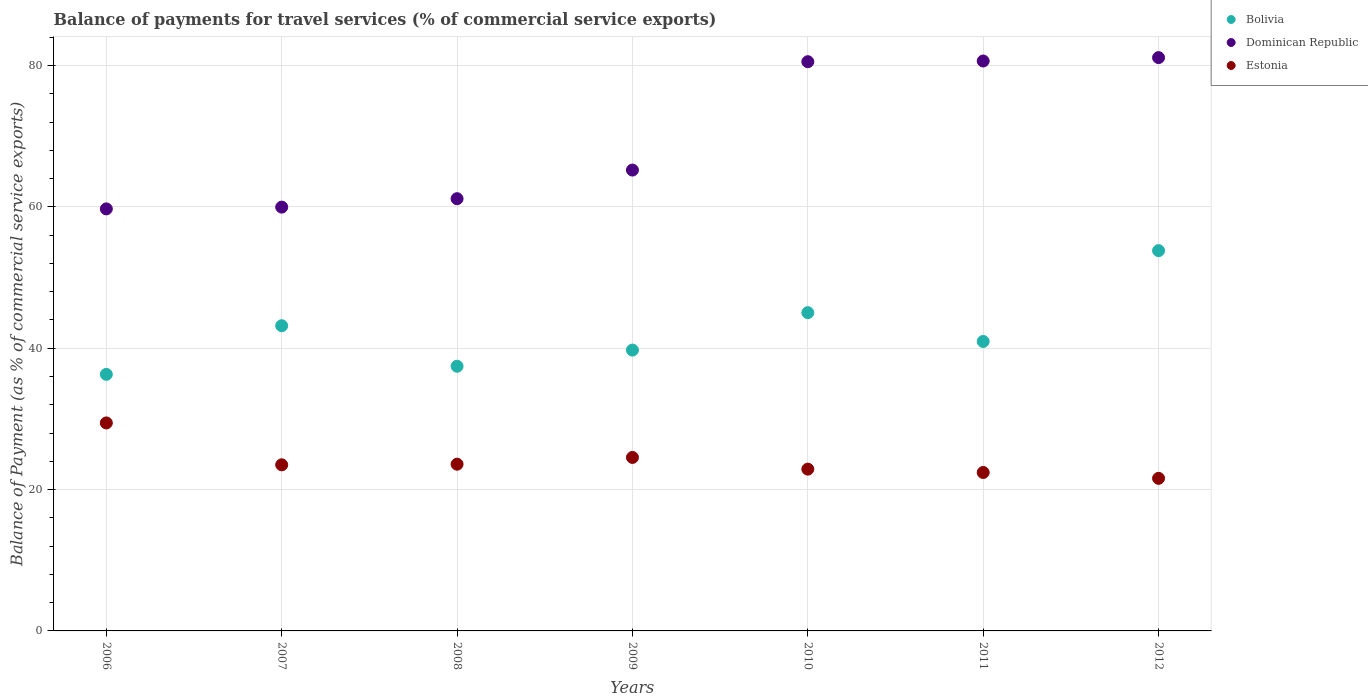How many different coloured dotlines are there?
Make the answer very short. 3. What is the balance of payments for travel services in Dominican Republic in 2009?
Offer a terse response. 65.2. Across all years, what is the maximum balance of payments for travel services in Bolivia?
Offer a very short reply. 53.8. Across all years, what is the minimum balance of payments for travel services in Dominican Republic?
Provide a short and direct response. 59.71. In which year was the balance of payments for travel services in Bolivia maximum?
Provide a short and direct response. 2012. In which year was the balance of payments for travel services in Bolivia minimum?
Give a very brief answer. 2006. What is the total balance of payments for travel services in Estonia in the graph?
Keep it short and to the point. 167.94. What is the difference between the balance of payments for travel services in Dominican Republic in 2007 and that in 2011?
Make the answer very short. -20.67. What is the difference between the balance of payments for travel services in Dominican Republic in 2006 and the balance of payments for travel services in Estonia in 2012?
Your answer should be compact. 38.12. What is the average balance of payments for travel services in Dominican Republic per year?
Your answer should be compact. 69.75. In the year 2007, what is the difference between the balance of payments for travel services in Dominican Republic and balance of payments for travel services in Estonia?
Provide a succinct answer. 36.46. What is the ratio of the balance of payments for travel services in Estonia in 2007 to that in 2009?
Provide a succinct answer. 0.96. Is the balance of payments for travel services in Dominican Republic in 2009 less than that in 2012?
Provide a short and direct response. Yes. Is the difference between the balance of payments for travel services in Dominican Republic in 2007 and 2011 greater than the difference between the balance of payments for travel services in Estonia in 2007 and 2011?
Provide a succinct answer. No. What is the difference between the highest and the second highest balance of payments for travel services in Estonia?
Your answer should be very brief. 4.88. What is the difference between the highest and the lowest balance of payments for travel services in Dominican Republic?
Make the answer very short. 21.4. Is it the case that in every year, the sum of the balance of payments for travel services in Bolivia and balance of payments for travel services in Estonia  is greater than the balance of payments for travel services in Dominican Republic?
Provide a succinct answer. No. Is the balance of payments for travel services in Bolivia strictly greater than the balance of payments for travel services in Dominican Republic over the years?
Your answer should be compact. No. Is the balance of payments for travel services in Estonia strictly less than the balance of payments for travel services in Dominican Republic over the years?
Keep it short and to the point. Yes. How many years are there in the graph?
Ensure brevity in your answer.  7. Does the graph contain grids?
Your response must be concise. Yes. Where does the legend appear in the graph?
Your response must be concise. Top right. What is the title of the graph?
Provide a succinct answer. Balance of payments for travel services (% of commercial service exports). What is the label or title of the Y-axis?
Provide a short and direct response. Balance of Payment (as % of commercial service exports). What is the Balance of Payment (as % of commercial service exports) in Bolivia in 2006?
Provide a short and direct response. 36.3. What is the Balance of Payment (as % of commercial service exports) in Dominican Republic in 2006?
Offer a terse response. 59.71. What is the Balance of Payment (as % of commercial service exports) in Estonia in 2006?
Your answer should be very brief. 29.43. What is the Balance of Payment (as % of commercial service exports) of Bolivia in 2007?
Provide a succinct answer. 43.18. What is the Balance of Payment (as % of commercial service exports) of Dominican Republic in 2007?
Ensure brevity in your answer.  59.96. What is the Balance of Payment (as % of commercial service exports) in Estonia in 2007?
Your response must be concise. 23.5. What is the Balance of Payment (as % of commercial service exports) of Bolivia in 2008?
Keep it short and to the point. 37.45. What is the Balance of Payment (as % of commercial service exports) in Dominican Republic in 2008?
Offer a very short reply. 61.15. What is the Balance of Payment (as % of commercial service exports) of Estonia in 2008?
Provide a succinct answer. 23.59. What is the Balance of Payment (as % of commercial service exports) of Bolivia in 2009?
Provide a short and direct response. 39.73. What is the Balance of Payment (as % of commercial service exports) of Dominican Republic in 2009?
Give a very brief answer. 65.2. What is the Balance of Payment (as % of commercial service exports) in Estonia in 2009?
Make the answer very short. 24.54. What is the Balance of Payment (as % of commercial service exports) of Bolivia in 2010?
Ensure brevity in your answer.  45.03. What is the Balance of Payment (as % of commercial service exports) of Dominican Republic in 2010?
Give a very brief answer. 80.53. What is the Balance of Payment (as % of commercial service exports) in Estonia in 2010?
Ensure brevity in your answer.  22.89. What is the Balance of Payment (as % of commercial service exports) of Bolivia in 2011?
Your answer should be compact. 40.95. What is the Balance of Payment (as % of commercial service exports) in Dominican Republic in 2011?
Ensure brevity in your answer.  80.63. What is the Balance of Payment (as % of commercial service exports) in Estonia in 2011?
Your answer should be compact. 22.41. What is the Balance of Payment (as % of commercial service exports) in Bolivia in 2012?
Your answer should be very brief. 53.8. What is the Balance of Payment (as % of commercial service exports) in Dominican Republic in 2012?
Your answer should be very brief. 81.11. What is the Balance of Payment (as % of commercial service exports) in Estonia in 2012?
Offer a very short reply. 21.59. Across all years, what is the maximum Balance of Payment (as % of commercial service exports) in Bolivia?
Your answer should be compact. 53.8. Across all years, what is the maximum Balance of Payment (as % of commercial service exports) in Dominican Republic?
Offer a terse response. 81.11. Across all years, what is the maximum Balance of Payment (as % of commercial service exports) of Estonia?
Your response must be concise. 29.43. Across all years, what is the minimum Balance of Payment (as % of commercial service exports) in Bolivia?
Your answer should be very brief. 36.3. Across all years, what is the minimum Balance of Payment (as % of commercial service exports) in Dominican Republic?
Give a very brief answer. 59.71. Across all years, what is the minimum Balance of Payment (as % of commercial service exports) in Estonia?
Your answer should be very brief. 21.59. What is the total Balance of Payment (as % of commercial service exports) in Bolivia in the graph?
Make the answer very short. 296.43. What is the total Balance of Payment (as % of commercial service exports) in Dominican Republic in the graph?
Your response must be concise. 488.28. What is the total Balance of Payment (as % of commercial service exports) in Estonia in the graph?
Your answer should be compact. 167.94. What is the difference between the Balance of Payment (as % of commercial service exports) in Bolivia in 2006 and that in 2007?
Give a very brief answer. -6.88. What is the difference between the Balance of Payment (as % of commercial service exports) of Dominican Republic in 2006 and that in 2007?
Offer a terse response. -0.25. What is the difference between the Balance of Payment (as % of commercial service exports) of Estonia in 2006 and that in 2007?
Make the answer very short. 5.93. What is the difference between the Balance of Payment (as % of commercial service exports) of Bolivia in 2006 and that in 2008?
Keep it short and to the point. -1.15. What is the difference between the Balance of Payment (as % of commercial service exports) in Dominican Republic in 2006 and that in 2008?
Offer a very short reply. -1.44. What is the difference between the Balance of Payment (as % of commercial service exports) in Estonia in 2006 and that in 2008?
Your answer should be compact. 5.84. What is the difference between the Balance of Payment (as % of commercial service exports) in Bolivia in 2006 and that in 2009?
Offer a very short reply. -3.43. What is the difference between the Balance of Payment (as % of commercial service exports) in Dominican Republic in 2006 and that in 2009?
Keep it short and to the point. -5.49. What is the difference between the Balance of Payment (as % of commercial service exports) in Estonia in 2006 and that in 2009?
Make the answer very short. 4.88. What is the difference between the Balance of Payment (as % of commercial service exports) of Bolivia in 2006 and that in 2010?
Offer a terse response. -8.73. What is the difference between the Balance of Payment (as % of commercial service exports) of Dominican Republic in 2006 and that in 2010?
Make the answer very short. -20.82. What is the difference between the Balance of Payment (as % of commercial service exports) in Estonia in 2006 and that in 2010?
Provide a short and direct response. 6.54. What is the difference between the Balance of Payment (as % of commercial service exports) of Bolivia in 2006 and that in 2011?
Offer a terse response. -4.65. What is the difference between the Balance of Payment (as % of commercial service exports) of Dominican Republic in 2006 and that in 2011?
Your answer should be compact. -20.92. What is the difference between the Balance of Payment (as % of commercial service exports) of Estonia in 2006 and that in 2011?
Your response must be concise. 7.01. What is the difference between the Balance of Payment (as % of commercial service exports) in Bolivia in 2006 and that in 2012?
Your answer should be compact. -17.5. What is the difference between the Balance of Payment (as % of commercial service exports) in Dominican Republic in 2006 and that in 2012?
Your response must be concise. -21.4. What is the difference between the Balance of Payment (as % of commercial service exports) in Estonia in 2006 and that in 2012?
Ensure brevity in your answer.  7.84. What is the difference between the Balance of Payment (as % of commercial service exports) in Bolivia in 2007 and that in 2008?
Your answer should be compact. 5.73. What is the difference between the Balance of Payment (as % of commercial service exports) in Dominican Republic in 2007 and that in 2008?
Make the answer very short. -1.19. What is the difference between the Balance of Payment (as % of commercial service exports) of Estonia in 2007 and that in 2008?
Offer a terse response. -0.09. What is the difference between the Balance of Payment (as % of commercial service exports) of Bolivia in 2007 and that in 2009?
Offer a very short reply. 3.45. What is the difference between the Balance of Payment (as % of commercial service exports) of Dominican Republic in 2007 and that in 2009?
Ensure brevity in your answer.  -5.24. What is the difference between the Balance of Payment (as % of commercial service exports) in Estonia in 2007 and that in 2009?
Your answer should be very brief. -1.04. What is the difference between the Balance of Payment (as % of commercial service exports) in Bolivia in 2007 and that in 2010?
Your answer should be compact. -1.85. What is the difference between the Balance of Payment (as % of commercial service exports) of Dominican Republic in 2007 and that in 2010?
Offer a very short reply. -20.57. What is the difference between the Balance of Payment (as % of commercial service exports) in Estonia in 2007 and that in 2010?
Provide a short and direct response. 0.61. What is the difference between the Balance of Payment (as % of commercial service exports) of Bolivia in 2007 and that in 2011?
Your response must be concise. 2.23. What is the difference between the Balance of Payment (as % of commercial service exports) of Dominican Republic in 2007 and that in 2011?
Your answer should be very brief. -20.67. What is the difference between the Balance of Payment (as % of commercial service exports) in Estonia in 2007 and that in 2011?
Your answer should be compact. 1.08. What is the difference between the Balance of Payment (as % of commercial service exports) of Bolivia in 2007 and that in 2012?
Give a very brief answer. -10.62. What is the difference between the Balance of Payment (as % of commercial service exports) in Dominican Republic in 2007 and that in 2012?
Offer a terse response. -21.15. What is the difference between the Balance of Payment (as % of commercial service exports) of Estonia in 2007 and that in 2012?
Make the answer very short. 1.91. What is the difference between the Balance of Payment (as % of commercial service exports) of Bolivia in 2008 and that in 2009?
Offer a very short reply. -2.29. What is the difference between the Balance of Payment (as % of commercial service exports) of Dominican Republic in 2008 and that in 2009?
Keep it short and to the point. -4.05. What is the difference between the Balance of Payment (as % of commercial service exports) in Estonia in 2008 and that in 2009?
Ensure brevity in your answer.  -0.96. What is the difference between the Balance of Payment (as % of commercial service exports) in Bolivia in 2008 and that in 2010?
Offer a very short reply. -7.58. What is the difference between the Balance of Payment (as % of commercial service exports) in Dominican Republic in 2008 and that in 2010?
Provide a succinct answer. -19.38. What is the difference between the Balance of Payment (as % of commercial service exports) in Estonia in 2008 and that in 2010?
Keep it short and to the point. 0.7. What is the difference between the Balance of Payment (as % of commercial service exports) of Bolivia in 2008 and that in 2011?
Ensure brevity in your answer.  -3.51. What is the difference between the Balance of Payment (as % of commercial service exports) of Dominican Republic in 2008 and that in 2011?
Provide a succinct answer. -19.48. What is the difference between the Balance of Payment (as % of commercial service exports) in Estonia in 2008 and that in 2011?
Offer a terse response. 1.17. What is the difference between the Balance of Payment (as % of commercial service exports) in Bolivia in 2008 and that in 2012?
Ensure brevity in your answer.  -16.35. What is the difference between the Balance of Payment (as % of commercial service exports) in Dominican Republic in 2008 and that in 2012?
Your answer should be very brief. -19.96. What is the difference between the Balance of Payment (as % of commercial service exports) in Estonia in 2008 and that in 2012?
Make the answer very short. 2. What is the difference between the Balance of Payment (as % of commercial service exports) of Bolivia in 2009 and that in 2010?
Provide a short and direct response. -5.3. What is the difference between the Balance of Payment (as % of commercial service exports) in Dominican Republic in 2009 and that in 2010?
Your answer should be very brief. -15.33. What is the difference between the Balance of Payment (as % of commercial service exports) in Estonia in 2009 and that in 2010?
Keep it short and to the point. 1.65. What is the difference between the Balance of Payment (as % of commercial service exports) in Bolivia in 2009 and that in 2011?
Provide a short and direct response. -1.22. What is the difference between the Balance of Payment (as % of commercial service exports) of Dominican Republic in 2009 and that in 2011?
Provide a short and direct response. -15.43. What is the difference between the Balance of Payment (as % of commercial service exports) of Estonia in 2009 and that in 2011?
Provide a succinct answer. 2.13. What is the difference between the Balance of Payment (as % of commercial service exports) in Bolivia in 2009 and that in 2012?
Your response must be concise. -14.07. What is the difference between the Balance of Payment (as % of commercial service exports) of Dominican Republic in 2009 and that in 2012?
Ensure brevity in your answer.  -15.91. What is the difference between the Balance of Payment (as % of commercial service exports) in Estonia in 2009 and that in 2012?
Offer a terse response. 2.96. What is the difference between the Balance of Payment (as % of commercial service exports) in Bolivia in 2010 and that in 2011?
Give a very brief answer. 4.08. What is the difference between the Balance of Payment (as % of commercial service exports) in Dominican Republic in 2010 and that in 2011?
Provide a short and direct response. -0.1. What is the difference between the Balance of Payment (as % of commercial service exports) of Estonia in 2010 and that in 2011?
Your answer should be very brief. 0.47. What is the difference between the Balance of Payment (as % of commercial service exports) of Bolivia in 2010 and that in 2012?
Your response must be concise. -8.77. What is the difference between the Balance of Payment (as % of commercial service exports) of Dominican Republic in 2010 and that in 2012?
Provide a succinct answer. -0.58. What is the difference between the Balance of Payment (as % of commercial service exports) in Estonia in 2010 and that in 2012?
Provide a short and direct response. 1.3. What is the difference between the Balance of Payment (as % of commercial service exports) in Bolivia in 2011 and that in 2012?
Offer a terse response. -12.85. What is the difference between the Balance of Payment (as % of commercial service exports) of Dominican Republic in 2011 and that in 2012?
Your response must be concise. -0.48. What is the difference between the Balance of Payment (as % of commercial service exports) in Estonia in 2011 and that in 2012?
Give a very brief answer. 0.83. What is the difference between the Balance of Payment (as % of commercial service exports) of Bolivia in 2006 and the Balance of Payment (as % of commercial service exports) of Dominican Republic in 2007?
Provide a succinct answer. -23.66. What is the difference between the Balance of Payment (as % of commercial service exports) of Bolivia in 2006 and the Balance of Payment (as % of commercial service exports) of Estonia in 2007?
Provide a short and direct response. 12.8. What is the difference between the Balance of Payment (as % of commercial service exports) of Dominican Republic in 2006 and the Balance of Payment (as % of commercial service exports) of Estonia in 2007?
Ensure brevity in your answer.  36.21. What is the difference between the Balance of Payment (as % of commercial service exports) in Bolivia in 2006 and the Balance of Payment (as % of commercial service exports) in Dominican Republic in 2008?
Provide a short and direct response. -24.85. What is the difference between the Balance of Payment (as % of commercial service exports) in Bolivia in 2006 and the Balance of Payment (as % of commercial service exports) in Estonia in 2008?
Make the answer very short. 12.71. What is the difference between the Balance of Payment (as % of commercial service exports) in Dominican Republic in 2006 and the Balance of Payment (as % of commercial service exports) in Estonia in 2008?
Offer a terse response. 36.12. What is the difference between the Balance of Payment (as % of commercial service exports) of Bolivia in 2006 and the Balance of Payment (as % of commercial service exports) of Dominican Republic in 2009?
Your answer should be very brief. -28.9. What is the difference between the Balance of Payment (as % of commercial service exports) in Bolivia in 2006 and the Balance of Payment (as % of commercial service exports) in Estonia in 2009?
Give a very brief answer. 11.75. What is the difference between the Balance of Payment (as % of commercial service exports) in Dominican Republic in 2006 and the Balance of Payment (as % of commercial service exports) in Estonia in 2009?
Your answer should be compact. 35.16. What is the difference between the Balance of Payment (as % of commercial service exports) of Bolivia in 2006 and the Balance of Payment (as % of commercial service exports) of Dominican Republic in 2010?
Your answer should be compact. -44.23. What is the difference between the Balance of Payment (as % of commercial service exports) of Bolivia in 2006 and the Balance of Payment (as % of commercial service exports) of Estonia in 2010?
Provide a short and direct response. 13.41. What is the difference between the Balance of Payment (as % of commercial service exports) of Dominican Republic in 2006 and the Balance of Payment (as % of commercial service exports) of Estonia in 2010?
Your answer should be very brief. 36.82. What is the difference between the Balance of Payment (as % of commercial service exports) in Bolivia in 2006 and the Balance of Payment (as % of commercial service exports) in Dominican Republic in 2011?
Offer a terse response. -44.33. What is the difference between the Balance of Payment (as % of commercial service exports) in Bolivia in 2006 and the Balance of Payment (as % of commercial service exports) in Estonia in 2011?
Your answer should be compact. 13.88. What is the difference between the Balance of Payment (as % of commercial service exports) of Dominican Republic in 2006 and the Balance of Payment (as % of commercial service exports) of Estonia in 2011?
Your answer should be very brief. 37.29. What is the difference between the Balance of Payment (as % of commercial service exports) in Bolivia in 2006 and the Balance of Payment (as % of commercial service exports) in Dominican Republic in 2012?
Provide a short and direct response. -44.81. What is the difference between the Balance of Payment (as % of commercial service exports) in Bolivia in 2006 and the Balance of Payment (as % of commercial service exports) in Estonia in 2012?
Your response must be concise. 14.71. What is the difference between the Balance of Payment (as % of commercial service exports) in Dominican Republic in 2006 and the Balance of Payment (as % of commercial service exports) in Estonia in 2012?
Keep it short and to the point. 38.12. What is the difference between the Balance of Payment (as % of commercial service exports) in Bolivia in 2007 and the Balance of Payment (as % of commercial service exports) in Dominican Republic in 2008?
Your response must be concise. -17.97. What is the difference between the Balance of Payment (as % of commercial service exports) of Bolivia in 2007 and the Balance of Payment (as % of commercial service exports) of Estonia in 2008?
Make the answer very short. 19.59. What is the difference between the Balance of Payment (as % of commercial service exports) of Dominican Republic in 2007 and the Balance of Payment (as % of commercial service exports) of Estonia in 2008?
Offer a very short reply. 36.37. What is the difference between the Balance of Payment (as % of commercial service exports) in Bolivia in 2007 and the Balance of Payment (as % of commercial service exports) in Dominican Republic in 2009?
Offer a terse response. -22.02. What is the difference between the Balance of Payment (as % of commercial service exports) in Bolivia in 2007 and the Balance of Payment (as % of commercial service exports) in Estonia in 2009?
Your answer should be very brief. 18.64. What is the difference between the Balance of Payment (as % of commercial service exports) of Dominican Republic in 2007 and the Balance of Payment (as % of commercial service exports) of Estonia in 2009?
Make the answer very short. 35.41. What is the difference between the Balance of Payment (as % of commercial service exports) of Bolivia in 2007 and the Balance of Payment (as % of commercial service exports) of Dominican Republic in 2010?
Your answer should be compact. -37.35. What is the difference between the Balance of Payment (as % of commercial service exports) of Bolivia in 2007 and the Balance of Payment (as % of commercial service exports) of Estonia in 2010?
Offer a very short reply. 20.29. What is the difference between the Balance of Payment (as % of commercial service exports) in Dominican Republic in 2007 and the Balance of Payment (as % of commercial service exports) in Estonia in 2010?
Make the answer very short. 37.07. What is the difference between the Balance of Payment (as % of commercial service exports) of Bolivia in 2007 and the Balance of Payment (as % of commercial service exports) of Dominican Republic in 2011?
Your answer should be compact. -37.45. What is the difference between the Balance of Payment (as % of commercial service exports) in Bolivia in 2007 and the Balance of Payment (as % of commercial service exports) in Estonia in 2011?
Provide a short and direct response. 20.76. What is the difference between the Balance of Payment (as % of commercial service exports) of Dominican Republic in 2007 and the Balance of Payment (as % of commercial service exports) of Estonia in 2011?
Offer a terse response. 37.54. What is the difference between the Balance of Payment (as % of commercial service exports) in Bolivia in 2007 and the Balance of Payment (as % of commercial service exports) in Dominican Republic in 2012?
Your response must be concise. -37.93. What is the difference between the Balance of Payment (as % of commercial service exports) of Bolivia in 2007 and the Balance of Payment (as % of commercial service exports) of Estonia in 2012?
Offer a terse response. 21.59. What is the difference between the Balance of Payment (as % of commercial service exports) of Dominican Republic in 2007 and the Balance of Payment (as % of commercial service exports) of Estonia in 2012?
Offer a very short reply. 38.37. What is the difference between the Balance of Payment (as % of commercial service exports) in Bolivia in 2008 and the Balance of Payment (as % of commercial service exports) in Dominican Republic in 2009?
Your answer should be compact. -27.75. What is the difference between the Balance of Payment (as % of commercial service exports) of Bolivia in 2008 and the Balance of Payment (as % of commercial service exports) of Estonia in 2009?
Your answer should be very brief. 12.9. What is the difference between the Balance of Payment (as % of commercial service exports) in Dominican Republic in 2008 and the Balance of Payment (as % of commercial service exports) in Estonia in 2009?
Provide a short and direct response. 36.61. What is the difference between the Balance of Payment (as % of commercial service exports) in Bolivia in 2008 and the Balance of Payment (as % of commercial service exports) in Dominican Republic in 2010?
Provide a succinct answer. -43.09. What is the difference between the Balance of Payment (as % of commercial service exports) in Bolivia in 2008 and the Balance of Payment (as % of commercial service exports) in Estonia in 2010?
Your answer should be compact. 14.56. What is the difference between the Balance of Payment (as % of commercial service exports) of Dominican Republic in 2008 and the Balance of Payment (as % of commercial service exports) of Estonia in 2010?
Your response must be concise. 38.26. What is the difference between the Balance of Payment (as % of commercial service exports) of Bolivia in 2008 and the Balance of Payment (as % of commercial service exports) of Dominican Republic in 2011?
Offer a very short reply. -43.18. What is the difference between the Balance of Payment (as % of commercial service exports) of Bolivia in 2008 and the Balance of Payment (as % of commercial service exports) of Estonia in 2011?
Keep it short and to the point. 15.03. What is the difference between the Balance of Payment (as % of commercial service exports) of Dominican Republic in 2008 and the Balance of Payment (as % of commercial service exports) of Estonia in 2011?
Offer a very short reply. 38.73. What is the difference between the Balance of Payment (as % of commercial service exports) in Bolivia in 2008 and the Balance of Payment (as % of commercial service exports) in Dominican Republic in 2012?
Offer a terse response. -43.66. What is the difference between the Balance of Payment (as % of commercial service exports) in Bolivia in 2008 and the Balance of Payment (as % of commercial service exports) in Estonia in 2012?
Your answer should be compact. 15.86. What is the difference between the Balance of Payment (as % of commercial service exports) in Dominican Republic in 2008 and the Balance of Payment (as % of commercial service exports) in Estonia in 2012?
Make the answer very short. 39.56. What is the difference between the Balance of Payment (as % of commercial service exports) in Bolivia in 2009 and the Balance of Payment (as % of commercial service exports) in Dominican Republic in 2010?
Give a very brief answer. -40.8. What is the difference between the Balance of Payment (as % of commercial service exports) in Bolivia in 2009 and the Balance of Payment (as % of commercial service exports) in Estonia in 2010?
Make the answer very short. 16.84. What is the difference between the Balance of Payment (as % of commercial service exports) of Dominican Republic in 2009 and the Balance of Payment (as % of commercial service exports) of Estonia in 2010?
Offer a very short reply. 42.31. What is the difference between the Balance of Payment (as % of commercial service exports) of Bolivia in 2009 and the Balance of Payment (as % of commercial service exports) of Dominican Republic in 2011?
Make the answer very short. -40.9. What is the difference between the Balance of Payment (as % of commercial service exports) of Bolivia in 2009 and the Balance of Payment (as % of commercial service exports) of Estonia in 2011?
Give a very brief answer. 17.32. What is the difference between the Balance of Payment (as % of commercial service exports) in Dominican Republic in 2009 and the Balance of Payment (as % of commercial service exports) in Estonia in 2011?
Offer a very short reply. 42.78. What is the difference between the Balance of Payment (as % of commercial service exports) in Bolivia in 2009 and the Balance of Payment (as % of commercial service exports) in Dominican Republic in 2012?
Provide a succinct answer. -41.38. What is the difference between the Balance of Payment (as % of commercial service exports) in Bolivia in 2009 and the Balance of Payment (as % of commercial service exports) in Estonia in 2012?
Ensure brevity in your answer.  18.14. What is the difference between the Balance of Payment (as % of commercial service exports) in Dominican Republic in 2009 and the Balance of Payment (as % of commercial service exports) in Estonia in 2012?
Offer a very short reply. 43.61. What is the difference between the Balance of Payment (as % of commercial service exports) of Bolivia in 2010 and the Balance of Payment (as % of commercial service exports) of Dominican Republic in 2011?
Ensure brevity in your answer.  -35.6. What is the difference between the Balance of Payment (as % of commercial service exports) in Bolivia in 2010 and the Balance of Payment (as % of commercial service exports) in Estonia in 2011?
Your response must be concise. 22.61. What is the difference between the Balance of Payment (as % of commercial service exports) in Dominican Republic in 2010 and the Balance of Payment (as % of commercial service exports) in Estonia in 2011?
Keep it short and to the point. 58.12. What is the difference between the Balance of Payment (as % of commercial service exports) in Bolivia in 2010 and the Balance of Payment (as % of commercial service exports) in Dominican Republic in 2012?
Provide a succinct answer. -36.08. What is the difference between the Balance of Payment (as % of commercial service exports) in Bolivia in 2010 and the Balance of Payment (as % of commercial service exports) in Estonia in 2012?
Offer a terse response. 23.44. What is the difference between the Balance of Payment (as % of commercial service exports) in Dominican Republic in 2010 and the Balance of Payment (as % of commercial service exports) in Estonia in 2012?
Offer a terse response. 58.94. What is the difference between the Balance of Payment (as % of commercial service exports) in Bolivia in 2011 and the Balance of Payment (as % of commercial service exports) in Dominican Republic in 2012?
Provide a succinct answer. -40.16. What is the difference between the Balance of Payment (as % of commercial service exports) in Bolivia in 2011 and the Balance of Payment (as % of commercial service exports) in Estonia in 2012?
Offer a very short reply. 19.36. What is the difference between the Balance of Payment (as % of commercial service exports) in Dominican Republic in 2011 and the Balance of Payment (as % of commercial service exports) in Estonia in 2012?
Provide a succinct answer. 59.04. What is the average Balance of Payment (as % of commercial service exports) in Bolivia per year?
Provide a succinct answer. 42.35. What is the average Balance of Payment (as % of commercial service exports) of Dominican Republic per year?
Your answer should be very brief. 69.75. What is the average Balance of Payment (as % of commercial service exports) in Estonia per year?
Your answer should be compact. 23.99. In the year 2006, what is the difference between the Balance of Payment (as % of commercial service exports) in Bolivia and Balance of Payment (as % of commercial service exports) in Dominican Republic?
Give a very brief answer. -23.41. In the year 2006, what is the difference between the Balance of Payment (as % of commercial service exports) of Bolivia and Balance of Payment (as % of commercial service exports) of Estonia?
Give a very brief answer. 6.87. In the year 2006, what is the difference between the Balance of Payment (as % of commercial service exports) of Dominican Republic and Balance of Payment (as % of commercial service exports) of Estonia?
Provide a short and direct response. 30.28. In the year 2007, what is the difference between the Balance of Payment (as % of commercial service exports) of Bolivia and Balance of Payment (as % of commercial service exports) of Dominican Republic?
Keep it short and to the point. -16.78. In the year 2007, what is the difference between the Balance of Payment (as % of commercial service exports) in Bolivia and Balance of Payment (as % of commercial service exports) in Estonia?
Keep it short and to the point. 19.68. In the year 2007, what is the difference between the Balance of Payment (as % of commercial service exports) in Dominican Republic and Balance of Payment (as % of commercial service exports) in Estonia?
Keep it short and to the point. 36.46. In the year 2008, what is the difference between the Balance of Payment (as % of commercial service exports) of Bolivia and Balance of Payment (as % of commercial service exports) of Dominican Republic?
Your answer should be very brief. -23.7. In the year 2008, what is the difference between the Balance of Payment (as % of commercial service exports) of Bolivia and Balance of Payment (as % of commercial service exports) of Estonia?
Offer a terse response. 13.86. In the year 2008, what is the difference between the Balance of Payment (as % of commercial service exports) of Dominican Republic and Balance of Payment (as % of commercial service exports) of Estonia?
Keep it short and to the point. 37.56. In the year 2009, what is the difference between the Balance of Payment (as % of commercial service exports) in Bolivia and Balance of Payment (as % of commercial service exports) in Dominican Republic?
Your response must be concise. -25.47. In the year 2009, what is the difference between the Balance of Payment (as % of commercial service exports) in Bolivia and Balance of Payment (as % of commercial service exports) in Estonia?
Make the answer very short. 15.19. In the year 2009, what is the difference between the Balance of Payment (as % of commercial service exports) of Dominican Republic and Balance of Payment (as % of commercial service exports) of Estonia?
Ensure brevity in your answer.  40.66. In the year 2010, what is the difference between the Balance of Payment (as % of commercial service exports) of Bolivia and Balance of Payment (as % of commercial service exports) of Dominican Republic?
Keep it short and to the point. -35.5. In the year 2010, what is the difference between the Balance of Payment (as % of commercial service exports) of Bolivia and Balance of Payment (as % of commercial service exports) of Estonia?
Give a very brief answer. 22.14. In the year 2010, what is the difference between the Balance of Payment (as % of commercial service exports) in Dominican Republic and Balance of Payment (as % of commercial service exports) in Estonia?
Keep it short and to the point. 57.64. In the year 2011, what is the difference between the Balance of Payment (as % of commercial service exports) of Bolivia and Balance of Payment (as % of commercial service exports) of Dominican Republic?
Ensure brevity in your answer.  -39.68. In the year 2011, what is the difference between the Balance of Payment (as % of commercial service exports) in Bolivia and Balance of Payment (as % of commercial service exports) in Estonia?
Make the answer very short. 18.54. In the year 2011, what is the difference between the Balance of Payment (as % of commercial service exports) of Dominican Republic and Balance of Payment (as % of commercial service exports) of Estonia?
Provide a short and direct response. 58.22. In the year 2012, what is the difference between the Balance of Payment (as % of commercial service exports) in Bolivia and Balance of Payment (as % of commercial service exports) in Dominican Republic?
Give a very brief answer. -27.31. In the year 2012, what is the difference between the Balance of Payment (as % of commercial service exports) in Bolivia and Balance of Payment (as % of commercial service exports) in Estonia?
Offer a terse response. 32.21. In the year 2012, what is the difference between the Balance of Payment (as % of commercial service exports) of Dominican Republic and Balance of Payment (as % of commercial service exports) of Estonia?
Ensure brevity in your answer.  59.52. What is the ratio of the Balance of Payment (as % of commercial service exports) in Bolivia in 2006 to that in 2007?
Make the answer very short. 0.84. What is the ratio of the Balance of Payment (as % of commercial service exports) of Dominican Republic in 2006 to that in 2007?
Offer a very short reply. 1. What is the ratio of the Balance of Payment (as % of commercial service exports) in Estonia in 2006 to that in 2007?
Your response must be concise. 1.25. What is the ratio of the Balance of Payment (as % of commercial service exports) in Bolivia in 2006 to that in 2008?
Provide a short and direct response. 0.97. What is the ratio of the Balance of Payment (as % of commercial service exports) in Dominican Republic in 2006 to that in 2008?
Your answer should be compact. 0.98. What is the ratio of the Balance of Payment (as % of commercial service exports) of Estonia in 2006 to that in 2008?
Your response must be concise. 1.25. What is the ratio of the Balance of Payment (as % of commercial service exports) in Bolivia in 2006 to that in 2009?
Offer a terse response. 0.91. What is the ratio of the Balance of Payment (as % of commercial service exports) of Dominican Republic in 2006 to that in 2009?
Provide a succinct answer. 0.92. What is the ratio of the Balance of Payment (as % of commercial service exports) of Estonia in 2006 to that in 2009?
Make the answer very short. 1.2. What is the ratio of the Balance of Payment (as % of commercial service exports) of Bolivia in 2006 to that in 2010?
Give a very brief answer. 0.81. What is the ratio of the Balance of Payment (as % of commercial service exports) of Dominican Republic in 2006 to that in 2010?
Offer a terse response. 0.74. What is the ratio of the Balance of Payment (as % of commercial service exports) in Estonia in 2006 to that in 2010?
Your answer should be compact. 1.29. What is the ratio of the Balance of Payment (as % of commercial service exports) in Bolivia in 2006 to that in 2011?
Offer a very short reply. 0.89. What is the ratio of the Balance of Payment (as % of commercial service exports) in Dominican Republic in 2006 to that in 2011?
Ensure brevity in your answer.  0.74. What is the ratio of the Balance of Payment (as % of commercial service exports) of Estonia in 2006 to that in 2011?
Make the answer very short. 1.31. What is the ratio of the Balance of Payment (as % of commercial service exports) of Bolivia in 2006 to that in 2012?
Your response must be concise. 0.67. What is the ratio of the Balance of Payment (as % of commercial service exports) in Dominican Republic in 2006 to that in 2012?
Provide a succinct answer. 0.74. What is the ratio of the Balance of Payment (as % of commercial service exports) of Estonia in 2006 to that in 2012?
Your response must be concise. 1.36. What is the ratio of the Balance of Payment (as % of commercial service exports) of Bolivia in 2007 to that in 2008?
Give a very brief answer. 1.15. What is the ratio of the Balance of Payment (as % of commercial service exports) in Dominican Republic in 2007 to that in 2008?
Offer a terse response. 0.98. What is the ratio of the Balance of Payment (as % of commercial service exports) in Bolivia in 2007 to that in 2009?
Provide a succinct answer. 1.09. What is the ratio of the Balance of Payment (as % of commercial service exports) in Dominican Republic in 2007 to that in 2009?
Keep it short and to the point. 0.92. What is the ratio of the Balance of Payment (as % of commercial service exports) in Estonia in 2007 to that in 2009?
Offer a terse response. 0.96. What is the ratio of the Balance of Payment (as % of commercial service exports) in Bolivia in 2007 to that in 2010?
Your answer should be compact. 0.96. What is the ratio of the Balance of Payment (as % of commercial service exports) in Dominican Republic in 2007 to that in 2010?
Offer a terse response. 0.74. What is the ratio of the Balance of Payment (as % of commercial service exports) in Estonia in 2007 to that in 2010?
Offer a very short reply. 1.03. What is the ratio of the Balance of Payment (as % of commercial service exports) of Bolivia in 2007 to that in 2011?
Your response must be concise. 1.05. What is the ratio of the Balance of Payment (as % of commercial service exports) in Dominican Republic in 2007 to that in 2011?
Provide a short and direct response. 0.74. What is the ratio of the Balance of Payment (as % of commercial service exports) in Estonia in 2007 to that in 2011?
Offer a very short reply. 1.05. What is the ratio of the Balance of Payment (as % of commercial service exports) of Bolivia in 2007 to that in 2012?
Your answer should be compact. 0.8. What is the ratio of the Balance of Payment (as % of commercial service exports) in Dominican Republic in 2007 to that in 2012?
Offer a terse response. 0.74. What is the ratio of the Balance of Payment (as % of commercial service exports) in Estonia in 2007 to that in 2012?
Ensure brevity in your answer.  1.09. What is the ratio of the Balance of Payment (as % of commercial service exports) in Bolivia in 2008 to that in 2009?
Offer a terse response. 0.94. What is the ratio of the Balance of Payment (as % of commercial service exports) of Dominican Republic in 2008 to that in 2009?
Your answer should be very brief. 0.94. What is the ratio of the Balance of Payment (as % of commercial service exports) in Estonia in 2008 to that in 2009?
Your answer should be very brief. 0.96. What is the ratio of the Balance of Payment (as % of commercial service exports) in Bolivia in 2008 to that in 2010?
Your response must be concise. 0.83. What is the ratio of the Balance of Payment (as % of commercial service exports) in Dominican Republic in 2008 to that in 2010?
Your answer should be very brief. 0.76. What is the ratio of the Balance of Payment (as % of commercial service exports) of Estonia in 2008 to that in 2010?
Keep it short and to the point. 1.03. What is the ratio of the Balance of Payment (as % of commercial service exports) of Bolivia in 2008 to that in 2011?
Provide a succinct answer. 0.91. What is the ratio of the Balance of Payment (as % of commercial service exports) of Dominican Republic in 2008 to that in 2011?
Keep it short and to the point. 0.76. What is the ratio of the Balance of Payment (as % of commercial service exports) of Estonia in 2008 to that in 2011?
Give a very brief answer. 1.05. What is the ratio of the Balance of Payment (as % of commercial service exports) in Bolivia in 2008 to that in 2012?
Your answer should be compact. 0.7. What is the ratio of the Balance of Payment (as % of commercial service exports) in Dominican Republic in 2008 to that in 2012?
Give a very brief answer. 0.75. What is the ratio of the Balance of Payment (as % of commercial service exports) of Estonia in 2008 to that in 2012?
Offer a terse response. 1.09. What is the ratio of the Balance of Payment (as % of commercial service exports) in Bolivia in 2009 to that in 2010?
Make the answer very short. 0.88. What is the ratio of the Balance of Payment (as % of commercial service exports) of Dominican Republic in 2009 to that in 2010?
Give a very brief answer. 0.81. What is the ratio of the Balance of Payment (as % of commercial service exports) of Estonia in 2009 to that in 2010?
Give a very brief answer. 1.07. What is the ratio of the Balance of Payment (as % of commercial service exports) in Bolivia in 2009 to that in 2011?
Ensure brevity in your answer.  0.97. What is the ratio of the Balance of Payment (as % of commercial service exports) in Dominican Republic in 2009 to that in 2011?
Provide a succinct answer. 0.81. What is the ratio of the Balance of Payment (as % of commercial service exports) of Estonia in 2009 to that in 2011?
Ensure brevity in your answer.  1.09. What is the ratio of the Balance of Payment (as % of commercial service exports) in Bolivia in 2009 to that in 2012?
Provide a succinct answer. 0.74. What is the ratio of the Balance of Payment (as % of commercial service exports) in Dominican Republic in 2009 to that in 2012?
Your answer should be compact. 0.8. What is the ratio of the Balance of Payment (as % of commercial service exports) in Estonia in 2009 to that in 2012?
Your response must be concise. 1.14. What is the ratio of the Balance of Payment (as % of commercial service exports) in Bolivia in 2010 to that in 2011?
Your answer should be compact. 1.1. What is the ratio of the Balance of Payment (as % of commercial service exports) of Dominican Republic in 2010 to that in 2011?
Offer a very short reply. 1. What is the ratio of the Balance of Payment (as % of commercial service exports) of Estonia in 2010 to that in 2011?
Make the answer very short. 1.02. What is the ratio of the Balance of Payment (as % of commercial service exports) in Bolivia in 2010 to that in 2012?
Offer a terse response. 0.84. What is the ratio of the Balance of Payment (as % of commercial service exports) of Dominican Republic in 2010 to that in 2012?
Offer a terse response. 0.99. What is the ratio of the Balance of Payment (as % of commercial service exports) in Estonia in 2010 to that in 2012?
Make the answer very short. 1.06. What is the ratio of the Balance of Payment (as % of commercial service exports) in Bolivia in 2011 to that in 2012?
Keep it short and to the point. 0.76. What is the ratio of the Balance of Payment (as % of commercial service exports) of Estonia in 2011 to that in 2012?
Your answer should be compact. 1.04. What is the difference between the highest and the second highest Balance of Payment (as % of commercial service exports) in Bolivia?
Offer a terse response. 8.77. What is the difference between the highest and the second highest Balance of Payment (as % of commercial service exports) in Dominican Republic?
Provide a short and direct response. 0.48. What is the difference between the highest and the second highest Balance of Payment (as % of commercial service exports) of Estonia?
Give a very brief answer. 4.88. What is the difference between the highest and the lowest Balance of Payment (as % of commercial service exports) of Bolivia?
Offer a terse response. 17.5. What is the difference between the highest and the lowest Balance of Payment (as % of commercial service exports) in Dominican Republic?
Provide a succinct answer. 21.4. What is the difference between the highest and the lowest Balance of Payment (as % of commercial service exports) in Estonia?
Your response must be concise. 7.84. 